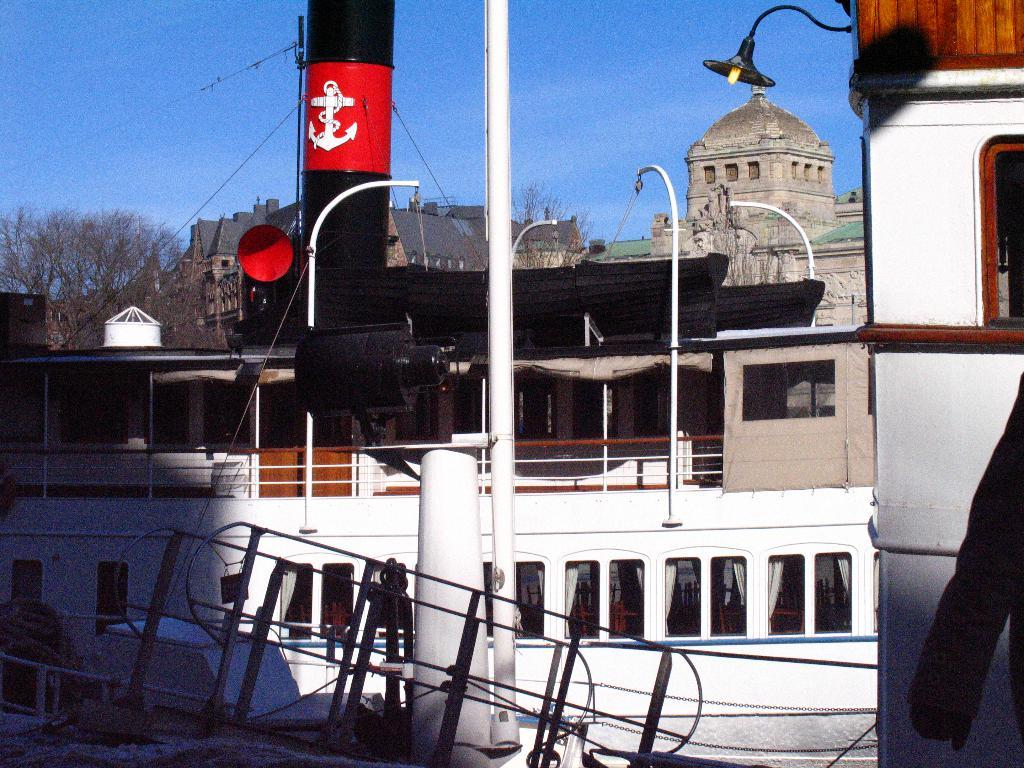What is the main object in the foreground of the image? There is a pole in the image. What can be seen in the background of the image? There are buildings and trees in the background of the image. Is there any source of light visible in the image? Yes, there is a light in the image. What is visible in the sky in the image? The sky is visible in the image. What type of vehicle is present in the image? There is a ship in the image. Where is the ship located in the image? The ship is on a water body. What type of sock is hanging from the pole in the image? There is no sock present in the image; it features a pole, buildings, trees, a light, the sky, a ship on a water body, but no sock. Can you describe the haircut of the person operating the ship in the image? There is no person operating the ship in the image, and therefore no haircut to describe. 